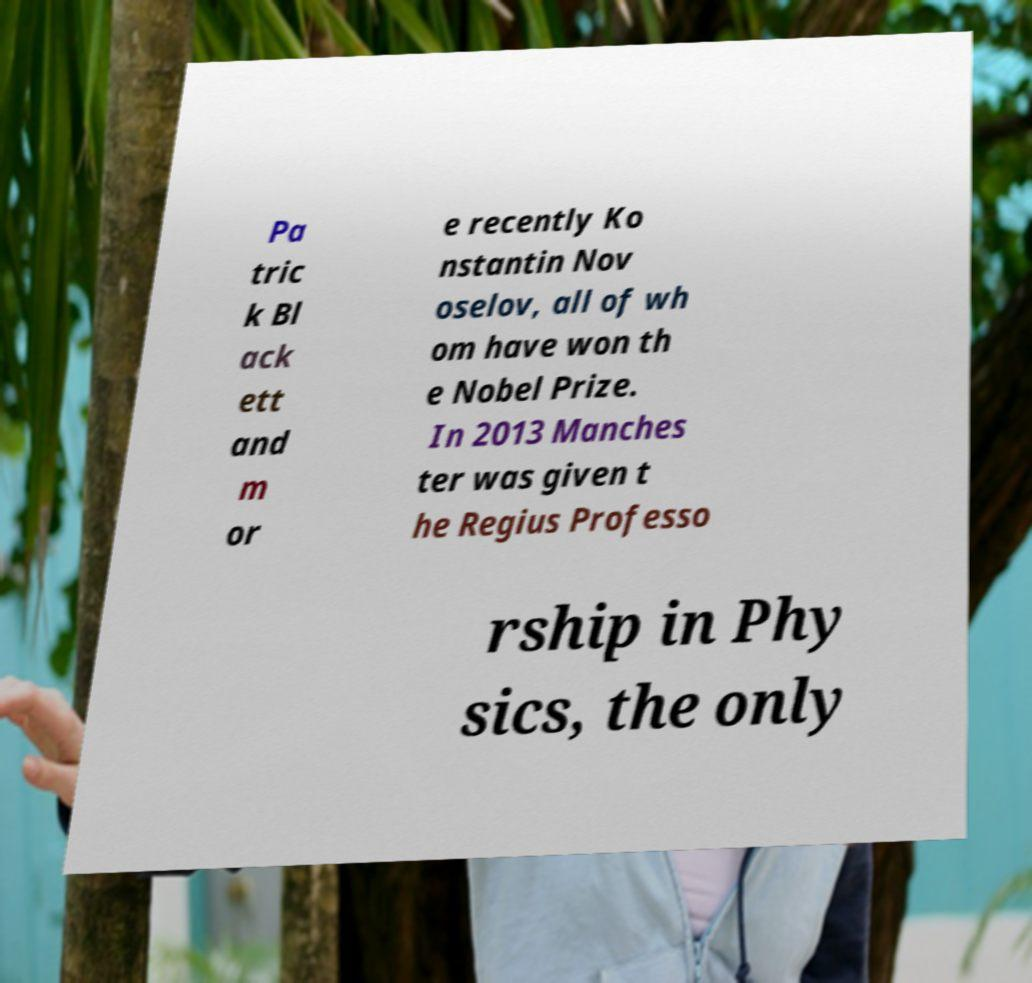What messages or text are displayed in this image? I need them in a readable, typed format. Pa tric k Bl ack ett and m or e recently Ko nstantin Nov oselov, all of wh om have won th e Nobel Prize. In 2013 Manches ter was given t he Regius Professo rship in Phy sics, the only 